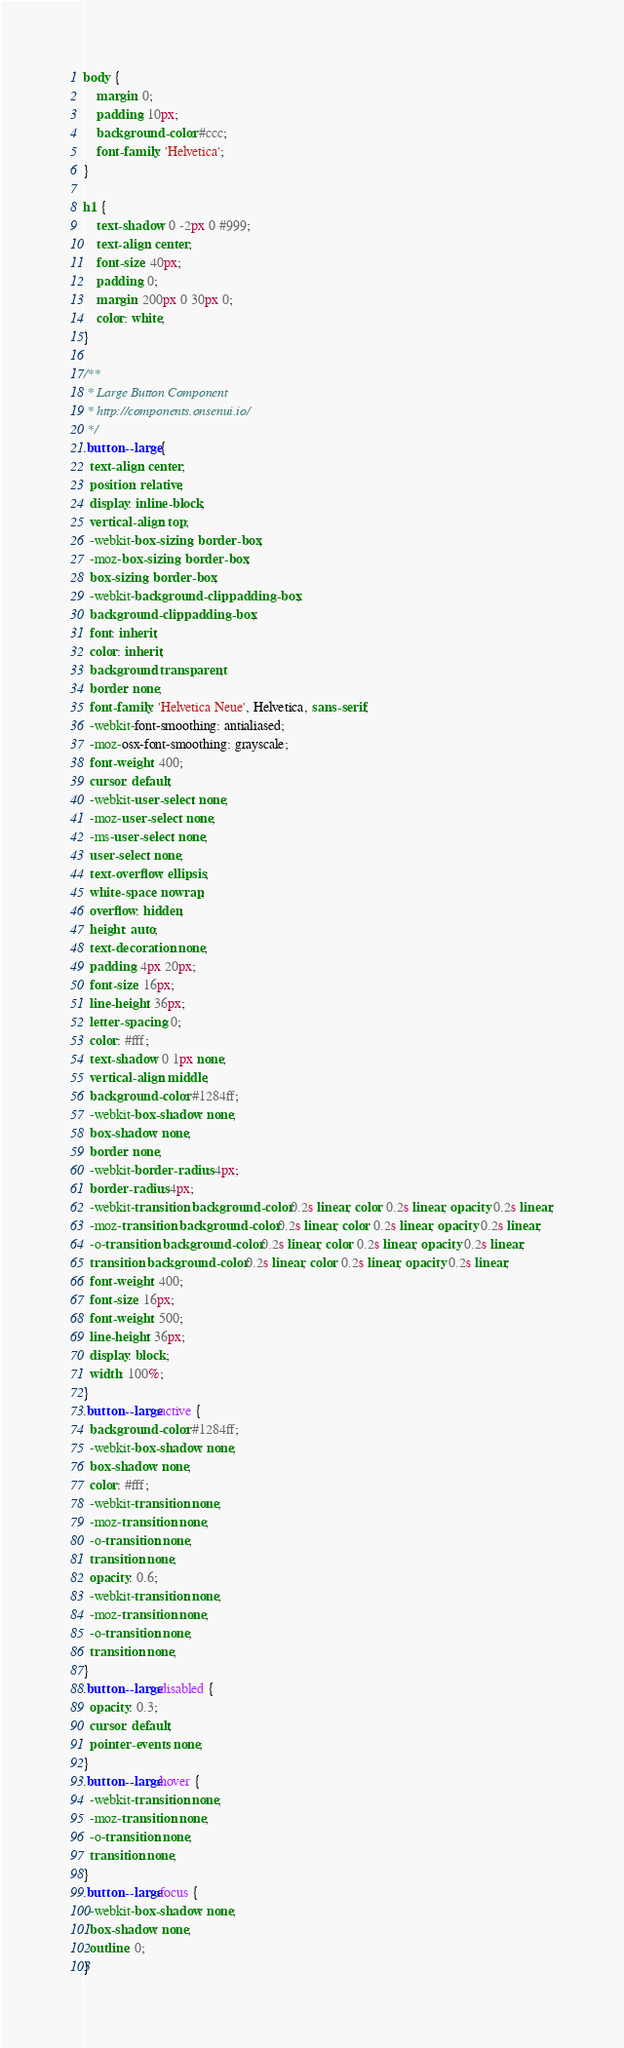Convert code to text. <code><loc_0><loc_0><loc_500><loc_500><_CSS_>body {
    margin: 0;
    padding: 10px;
    background-color: #ccc;
    font-family: 'Helvetica';
}

h1 {
    text-shadow: 0 -2px 0 #999;
    text-align: center;
    font-size: 40px;
    padding: 0;
    margin: 200px 0 30px 0;
    color: white;
}

/**
 * Large Button Component
 * http://components.onsenui.io/
 */
.button--large {
  text-align: center;
  position: relative;
  display: inline-block;
  vertical-align: top;
  -webkit-box-sizing: border-box;
  -moz-box-sizing: border-box;
  box-sizing: border-box;
  -webkit-background-clip: padding-box;
  background-clip: padding-box;
  font: inherit;
  color: inherit;
  background: transparent;
  border: none;
  font-family: 'Helvetica Neue', Helvetica, sans-serif;
  -webkit-font-smoothing: antialiased;
  -moz-osx-font-smoothing: grayscale;
  font-weight: 400;
  cursor: default;
  -webkit-user-select: none;
  -moz-user-select: none;
  -ms-user-select: none;
  user-select: none;
  text-overflow: ellipsis;
  white-space: nowrap;
  overflow: hidden;
  height: auto;
  text-decoration: none;
  padding: 4px 20px;
  font-size: 16px;
  line-height: 36px;
  letter-spacing: 0;
  color: #fff;
  text-shadow: 0 1px none;
  vertical-align: middle;
  background-color: #1284ff;
  -webkit-box-shadow: none;
  box-shadow: none;
  border: none;
  -webkit-border-radius: 4px;
  border-radius: 4px;
  -webkit-transition: background-color 0.2s linear, color 0.2s linear, opacity 0.2s linear;
  -moz-transition: background-color 0.2s linear, color 0.2s linear, opacity 0.2s linear;
  -o-transition: background-color 0.2s linear, color 0.2s linear, opacity 0.2s linear;
  transition: background-color 0.2s linear, color 0.2s linear, opacity 0.2s linear;
  font-weight: 400;
  font-size: 16px;
  font-weight: 500;
  line-height: 36px;
  display: block;
  width: 100%;
}
.button--large:active {
  background-color: #1284ff;
  -webkit-box-shadow: none;
  box-shadow: none;
  color: #fff;
  -webkit-transition: none;
  -moz-transition: none;
  -o-transition: none;
  transition: none;
  opacity: 0.6;
  -webkit-transition: none;
  -moz-transition: none;
  -o-transition: none;
  transition: none;
}
.button--large:disabled {
  opacity: 0.3;
  cursor: default;
  pointer-events: none;
}
.button--large:hover {
  -webkit-transition: none;
  -moz-transition: none;
  -o-transition: none;
  transition: none;
}
.button--large:focus {
  -webkit-box-shadow: none;
  box-shadow: none;
  outline: 0;
}</code> 